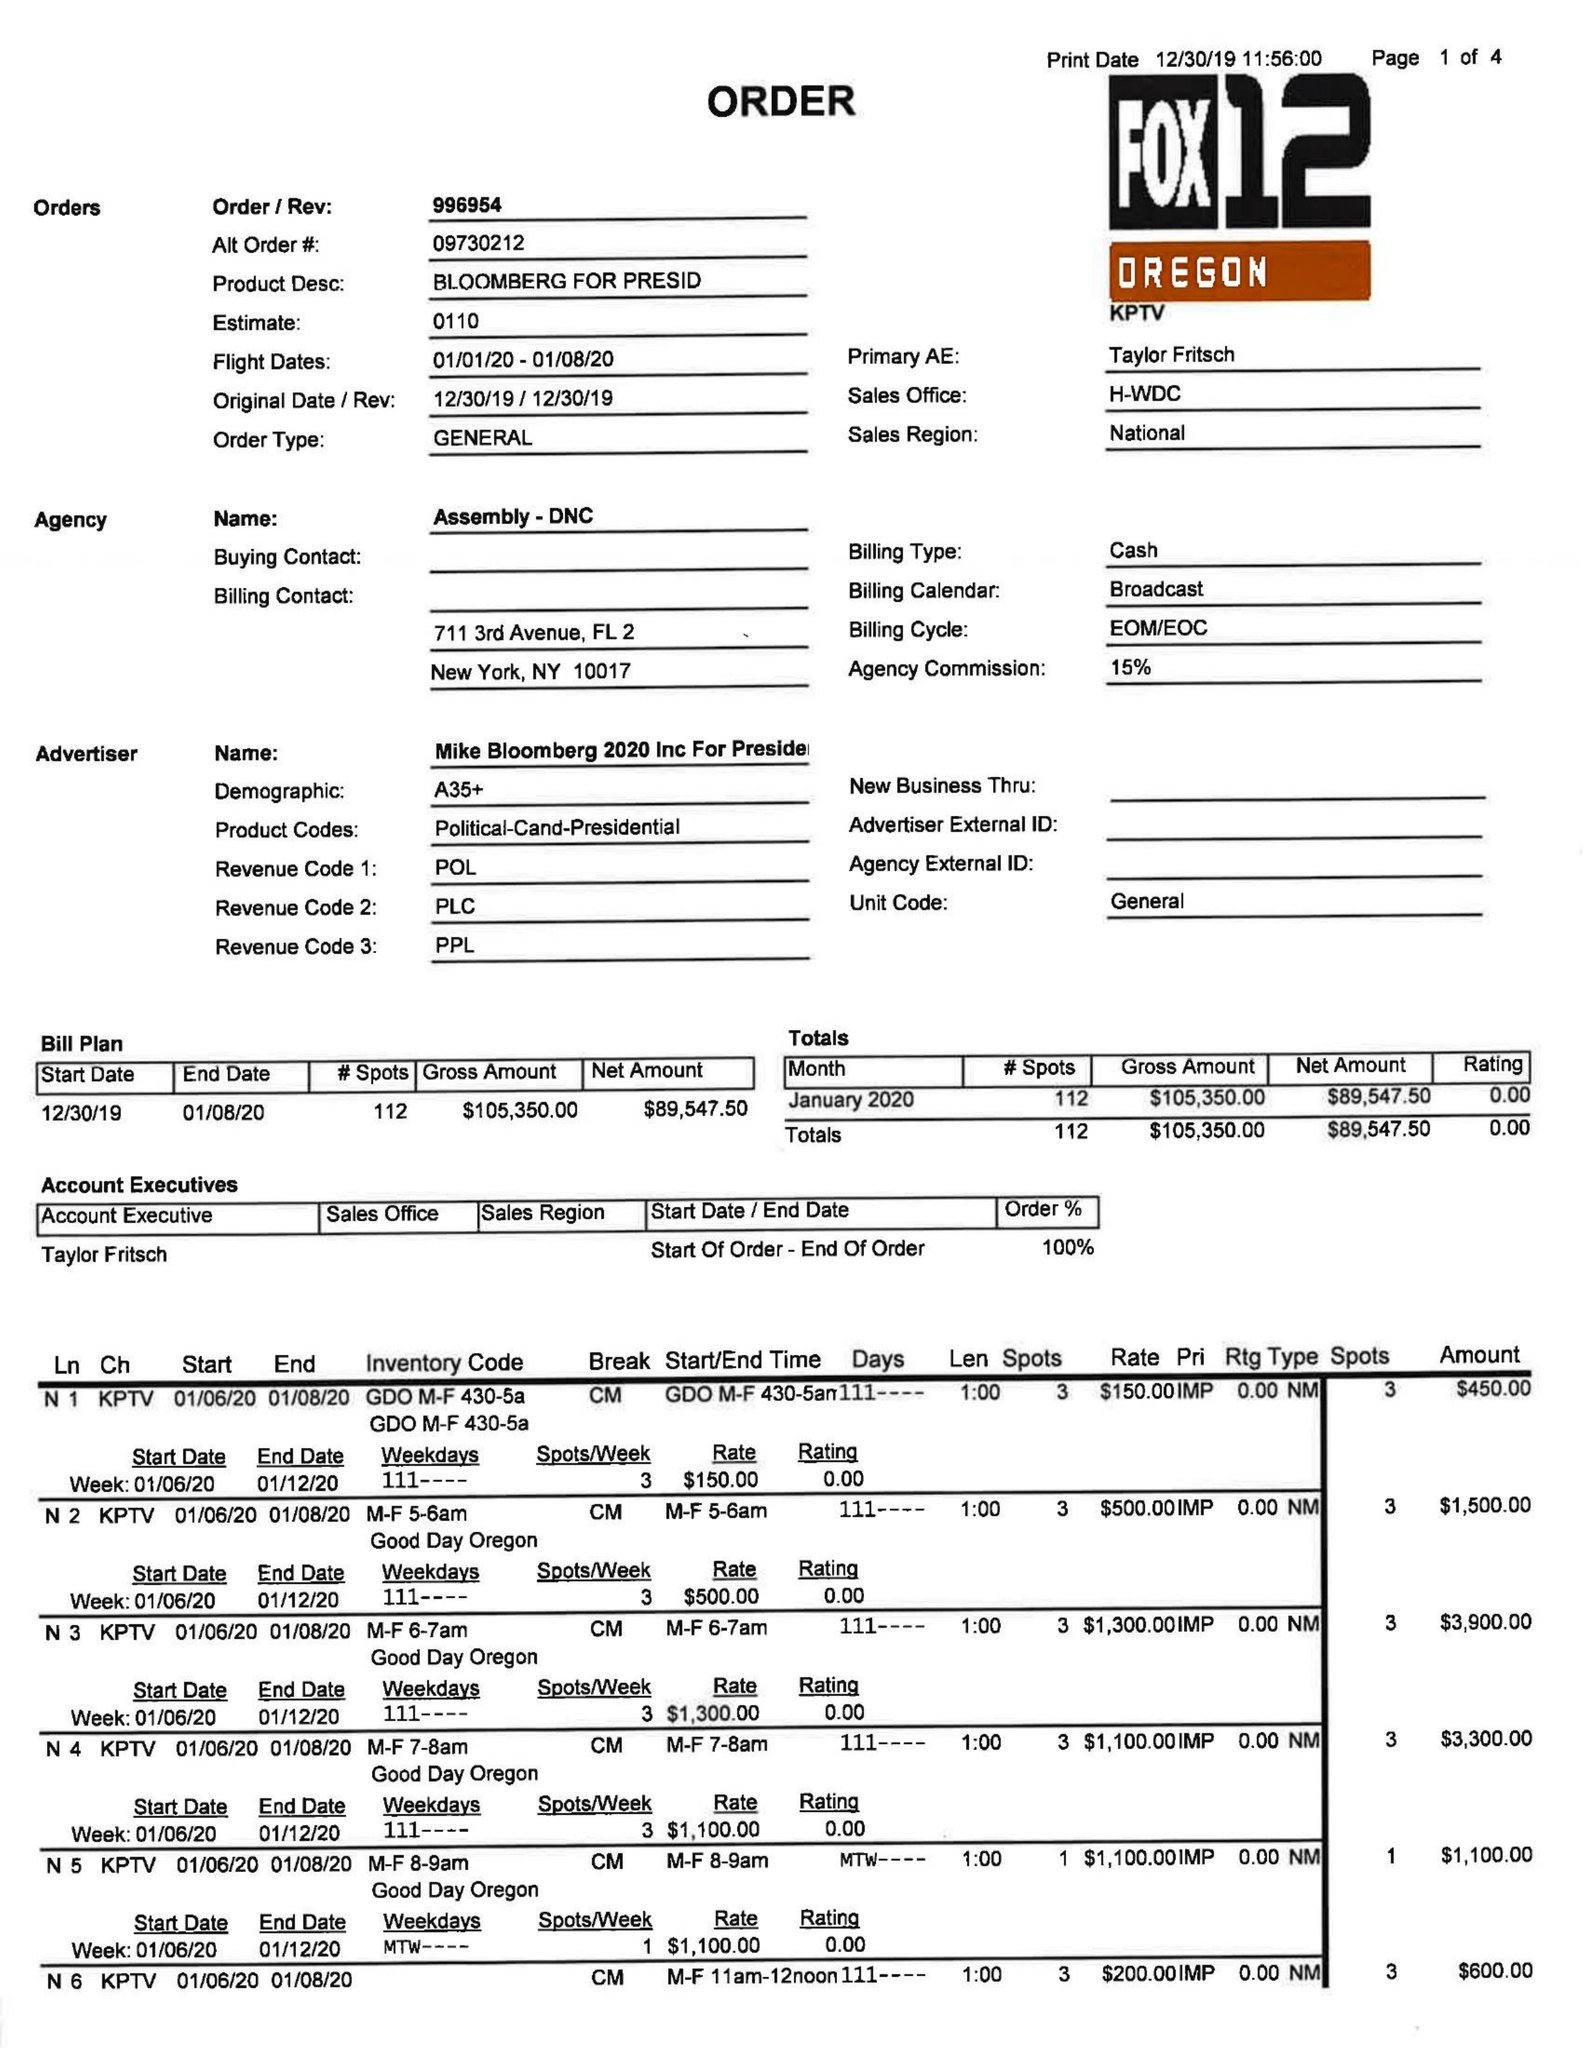What is the value for the contract_num?
Answer the question using a single word or phrase. 996954 